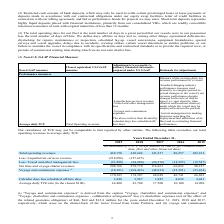From Golar Lng's financial document, In which years was the total operating revenues to average daily TCE recorded for? The document contains multiple relevant values: 2019, 2018, 2017, 2016, 2015. From the document: "Years Ended December 31, 2019 2018 2017 2016 2015 Years Ended December 31, 2019 2018 2017 2016 2015 Years Ended December 31, 2019 2018 2017 2016 2015 ..." Also, How was the average daily vessel operating cost calculated? Based on the financial document, the answer is By dividing vessel operating costs by the number of calendar days. Also, What was the charterhire expenses in 2017? According to the financial document, $12.4 million. The relevant text states: "he related guarantee obligation) of $nil, $nil and $12.4 million for the years ended December 31, 2019, 2018 and 2017, respectively, which arose on the charter-back..." Additionally, In which year was the net time and voyage charter revenues the highest? According to the financial document, 2018. The relevant text states: "Years Ended December 31, 2019 2018 2017 2016 2015..." Also, can you calculate: What was the change in total operating revenues from 2016 to 2017? Based on the calculation: 143,537 - 80,257 , the result is 63280 (in thousands). This is based on the information: "Total operating revenues 448,750 430,604 143,537 80,257 102,674 Less: Liquefaction services revenue (218,096) (127,625) — — — Less: Vessel and other manage al data) Total operating revenues 448,750 43..." The key data points involved are: 143,537, 80,257. Also, can you calculate: What was the percentage change in average daily TCE rate from 2018 to 2019? To answer this question, I need to perform calculations using the financial data. The calculation is: (44,400 - 43,700)/43,700 , which equals 1.6 (percentage). This is based on the information: "erage daily TCE rate (to the closest $100) 44,400 43,700 17,500 10,100 14,900 ,481 Average daily TCE rate (to the closest $100) 44,400 43,700 17,500 10,100 14,900..." The key data points involved are: 43,700, 44,400. 